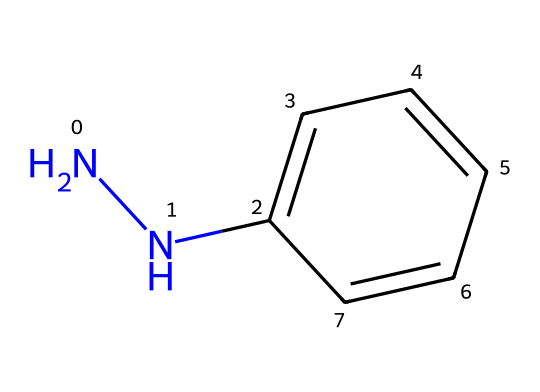What is the molecular formula of phenylhydrazine? The molecular composition can be deduced from the SMILES representation. The fragment 'NN' indicates two nitrogen atoms, 'c1ccccc1' indicates a phenyl ring which includes six carbon atoms and five hydrogen atoms due to the presence of one nitrogen substitution in the ring. Therefore, combining these gives a total of 6 carbons, 7 hydrogens, and 2 nitrogens resulting in the empirical formula C6H7N2.
Answer: C6H7N2 How many nitrogen atoms are present? Analyzing the SMILES notation, 'NN' indicates that there are two nitrogen atoms.
Answer: 2 What is the primary functional group in phenylhydrazine? The presence of 'NN' shows that the hydrazine functional group is present, which defines phenylhydrazine. This group is characterized by a nitrogen-nitrogen bond.
Answer: hydrazine How many hydrogen atoms are attached to the carbon atoms in the phenyl ring? The phenyl ring is represented by 'c1ccccc1', which has six carbon atoms in a cyclic arrangement. Since one hydrogen is replaced by a nitrogen atom, there will be five remaining hydrogen atoms attached to the carbons in the ring, totaling 5 hydrogen atoms.
Answer: 5 What is the significance of the phenyl group in this chemical? The phenyl group (C6H5) affects the chemical properties such as reactivity and stability due to its resonance and electron-donating effects, which add to the stability of the hydrazine derivative.
Answer: stability What type of compound is phenylhydrazine classified as? Based on the structure and functional group, phenylhydrazine belongs to the category of hydrazines, which are a specific class of organic compounds containing nitrogen.
Answer: hydrazine What is the overall charge of phenylhydrazine? The structure has no formal charges shown, indicating it is neutral in nature. All atoms follow normal bonding rules, and there are no extra charges present.
Answer: neutral 